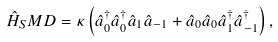Convert formula to latex. <formula><loc_0><loc_0><loc_500><loc_500>\hat { H } _ { S } M D = \kappa \left ( \hat { a } ^ { \dagger } _ { 0 } \hat { a } ^ { \dagger } _ { 0 } \hat { a } _ { 1 } \hat { a } _ { - 1 } + \hat { a } _ { 0 } \hat { a } _ { 0 } \hat { a } ^ { \dagger } _ { 1 } \hat { a } ^ { \dagger } _ { - 1 } \right ) ,</formula> 